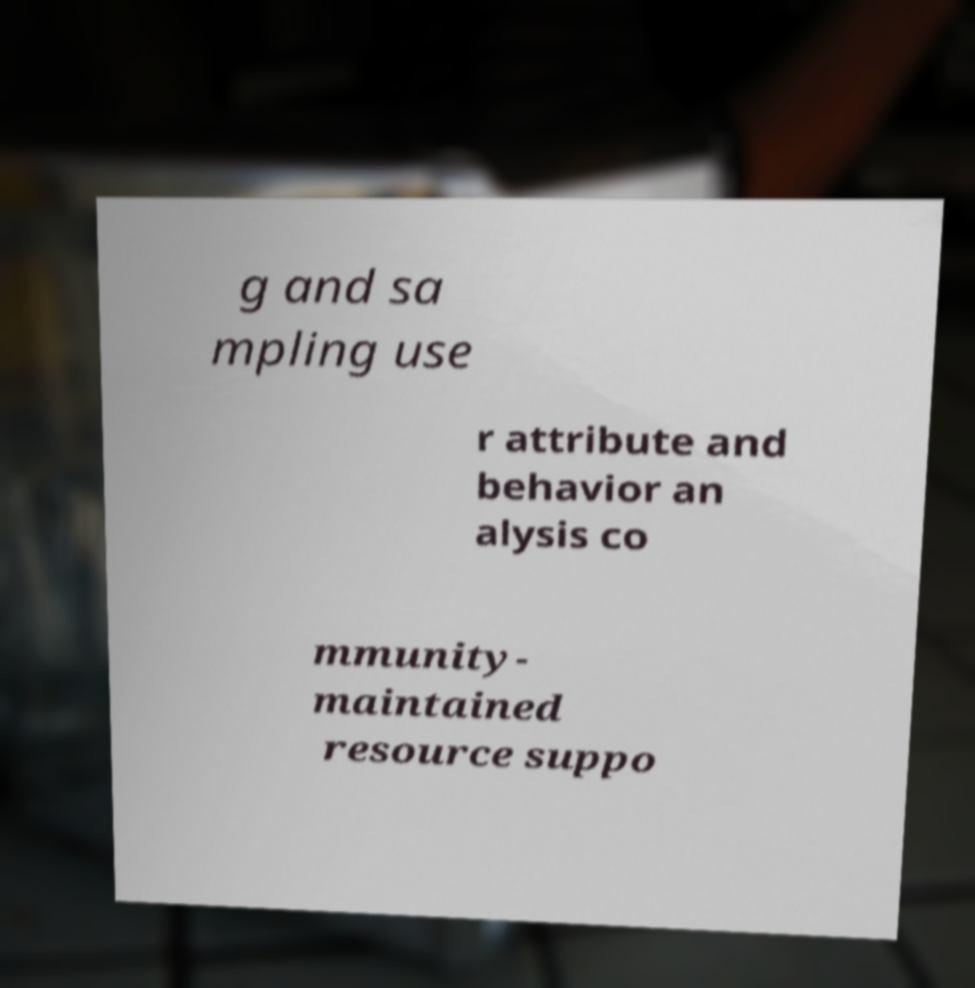What messages or text are displayed in this image? I need them in a readable, typed format. g and sa mpling use r attribute and behavior an alysis co mmunity- maintained resource suppo 